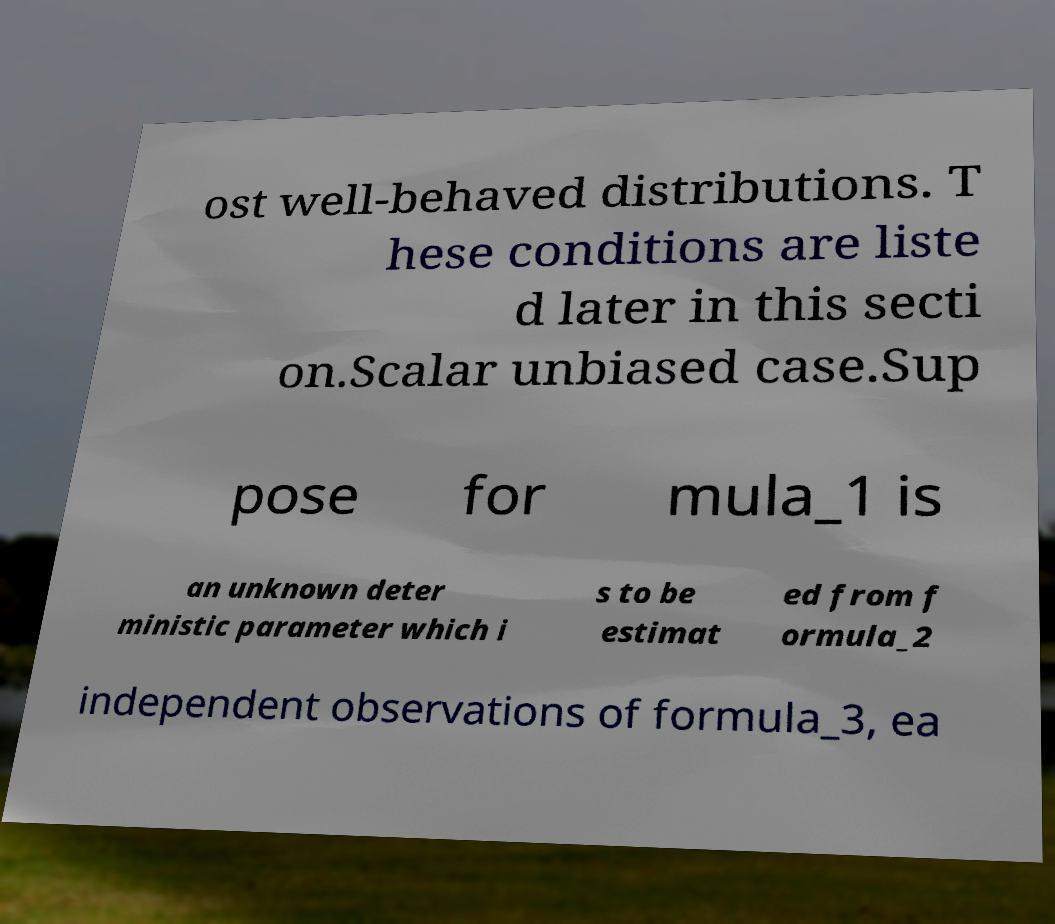There's text embedded in this image that I need extracted. Can you transcribe it verbatim? ost well-behaved distributions. T hese conditions are liste d later in this secti on.Scalar unbiased case.Sup pose for mula_1 is an unknown deter ministic parameter which i s to be estimat ed from f ormula_2 independent observations of formula_3, ea 